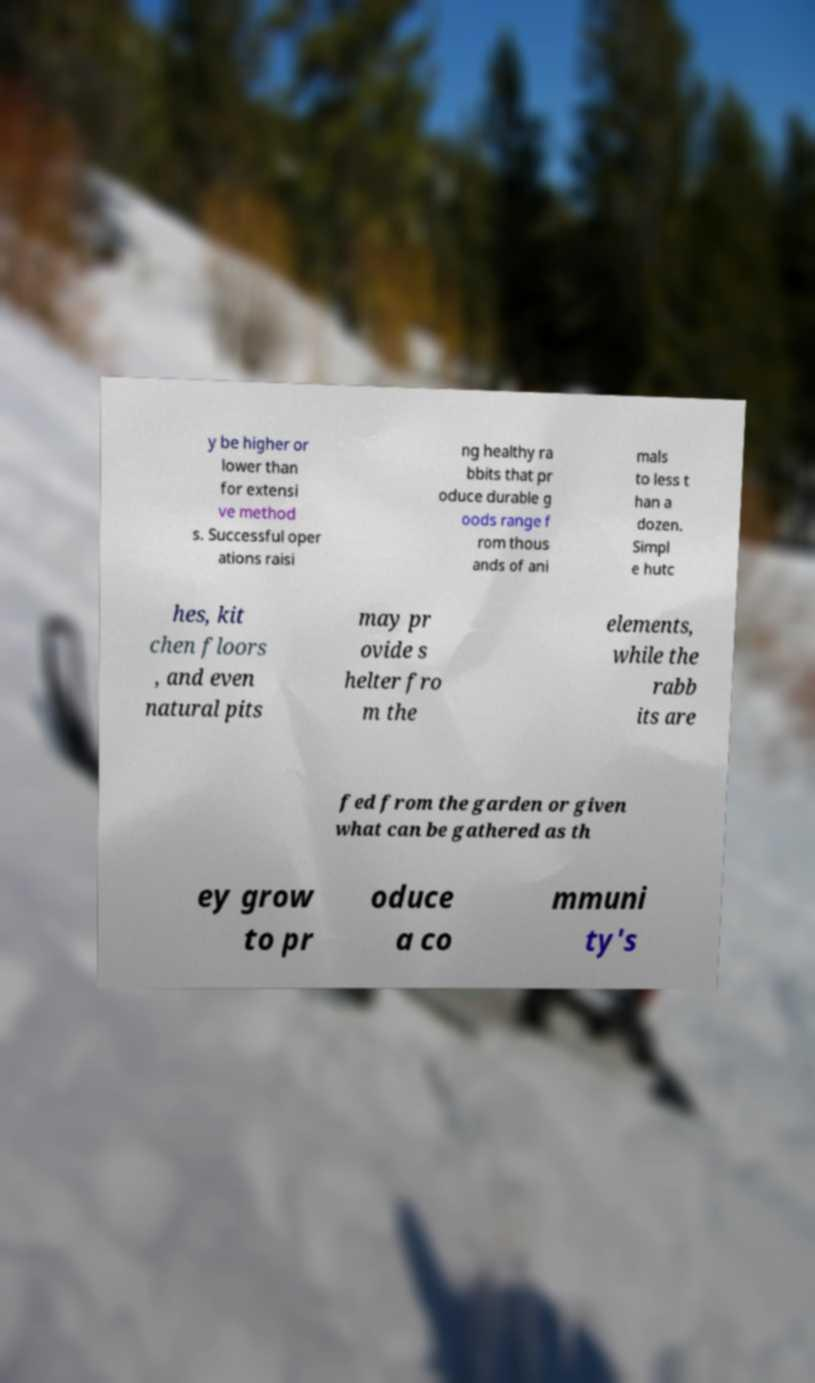Can you read and provide the text displayed in the image?This photo seems to have some interesting text. Can you extract and type it out for me? y be higher or lower than for extensi ve method s. Successful oper ations raisi ng healthy ra bbits that pr oduce durable g oods range f rom thous ands of ani mals to less t han a dozen. Simpl e hutc hes, kit chen floors , and even natural pits may pr ovide s helter fro m the elements, while the rabb its are fed from the garden or given what can be gathered as th ey grow to pr oduce a co mmuni ty's 